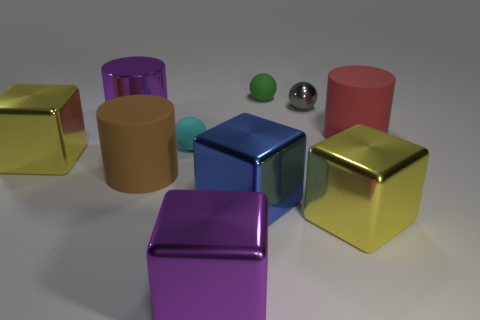Do the objects in the image appear to have any texture differences? Yes, the objects exhibit a variety of textures. The metal cubes and sphere have smooth, reflective surfaces that contrast with the matte finish of the small sphere and the red cylinder. The green rubber ball appears to have a slightly rough, less reflective texture compared to the metal objects. 